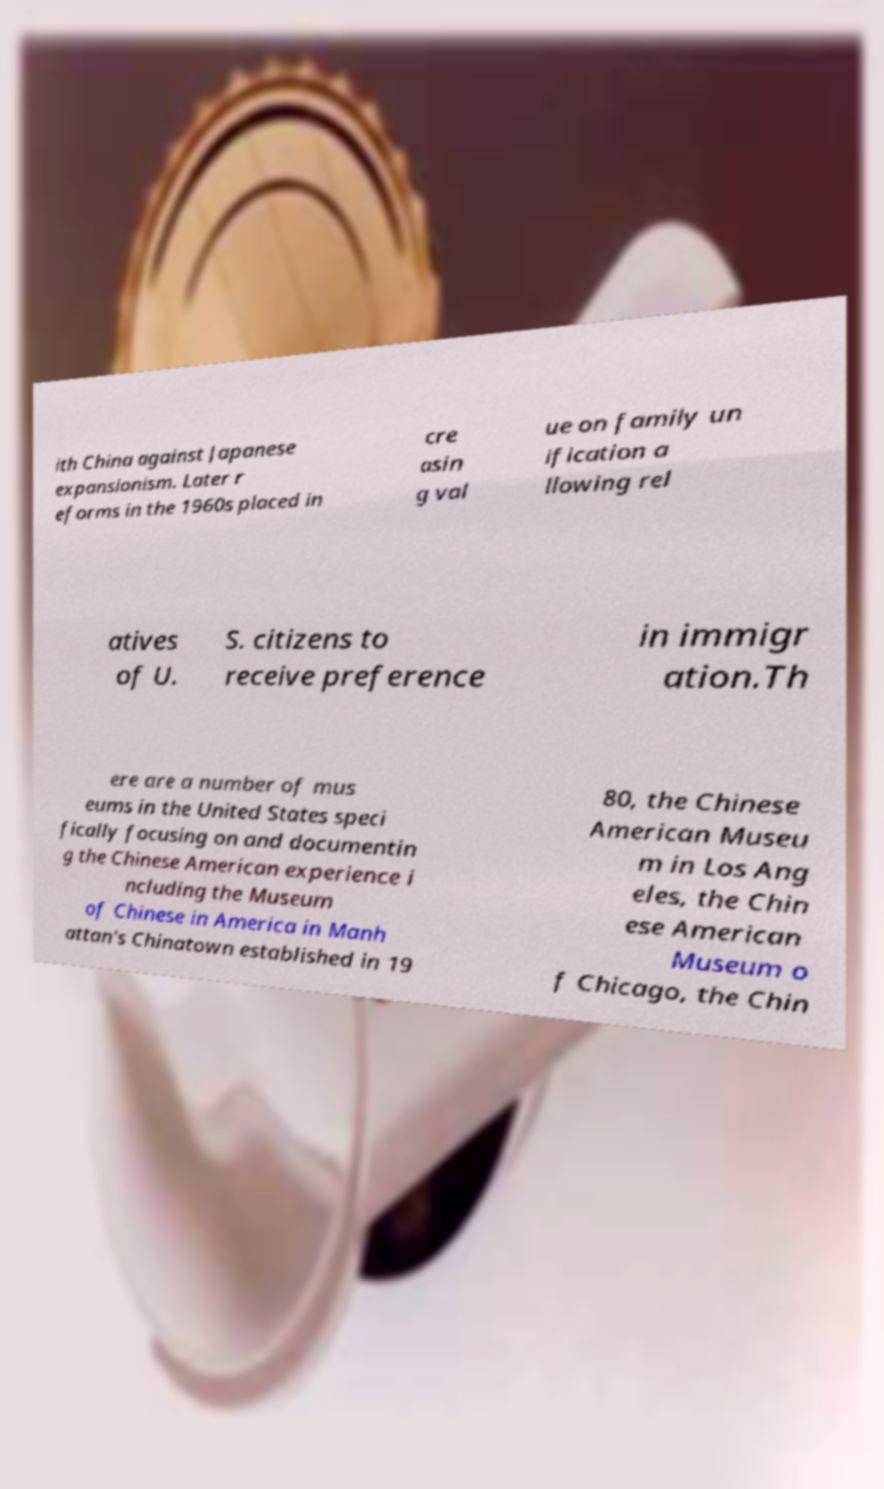There's text embedded in this image that I need extracted. Can you transcribe it verbatim? ith China against Japanese expansionism. Later r eforms in the 1960s placed in cre asin g val ue on family un ification a llowing rel atives of U. S. citizens to receive preference in immigr ation.Th ere are a number of mus eums in the United States speci fically focusing on and documentin g the Chinese American experience i ncluding the Museum of Chinese in America in Manh attan's Chinatown established in 19 80, the Chinese American Museu m in Los Ang eles, the Chin ese American Museum o f Chicago, the Chin 